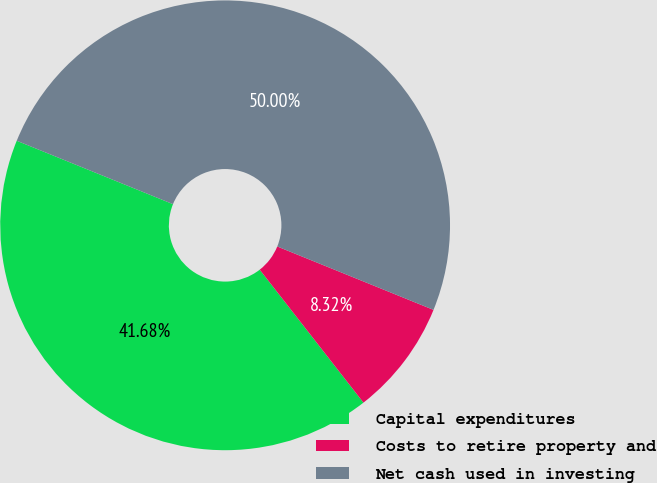Convert chart to OTSL. <chart><loc_0><loc_0><loc_500><loc_500><pie_chart><fcel>Capital expenditures<fcel>Costs to retire property and<fcel>Net cash used in investing<nl><fcel>41.68%<fcel>8.32%<fcel>50.0%<nl></chart> 